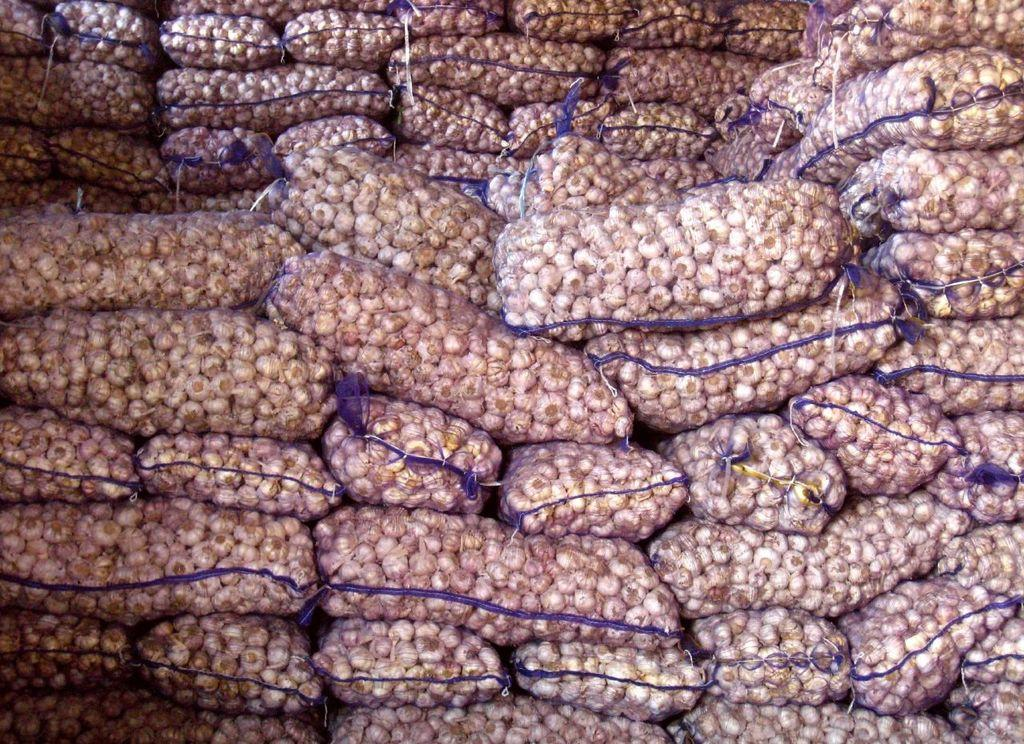What objects are present in the image? There are bags in the image. What is inside the bags? The bags contain garlic. What type of island can be seen in the image? There is no island present in the image; it features bags containing garlic. What scent is associated with the bags in the image? The provided facts do not mention any scent associated with the bags or their contents. 